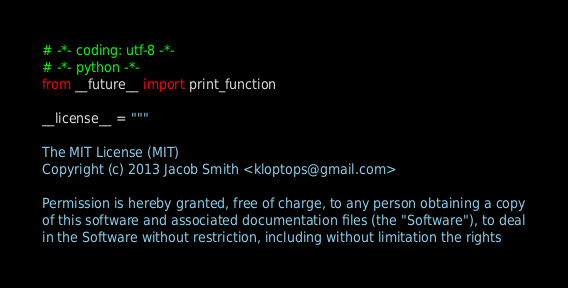<code> <loc_0><loc_0><loc_500><loc_500><_Python_># -*- coding: utf-8 -*-
# -*- python -*-
from __future__ import print_function

__license__ = """

The MIT License (MIT)
Copyright (c) 2013 Jacob Smith <kloptops@gmail.com>

Permission is hereby granted, free of charge, to any person obtaining a copy
of this software and associated documentation files (the "Software"), to deal
in the Software without restriction, including without limitation the rights</code> 